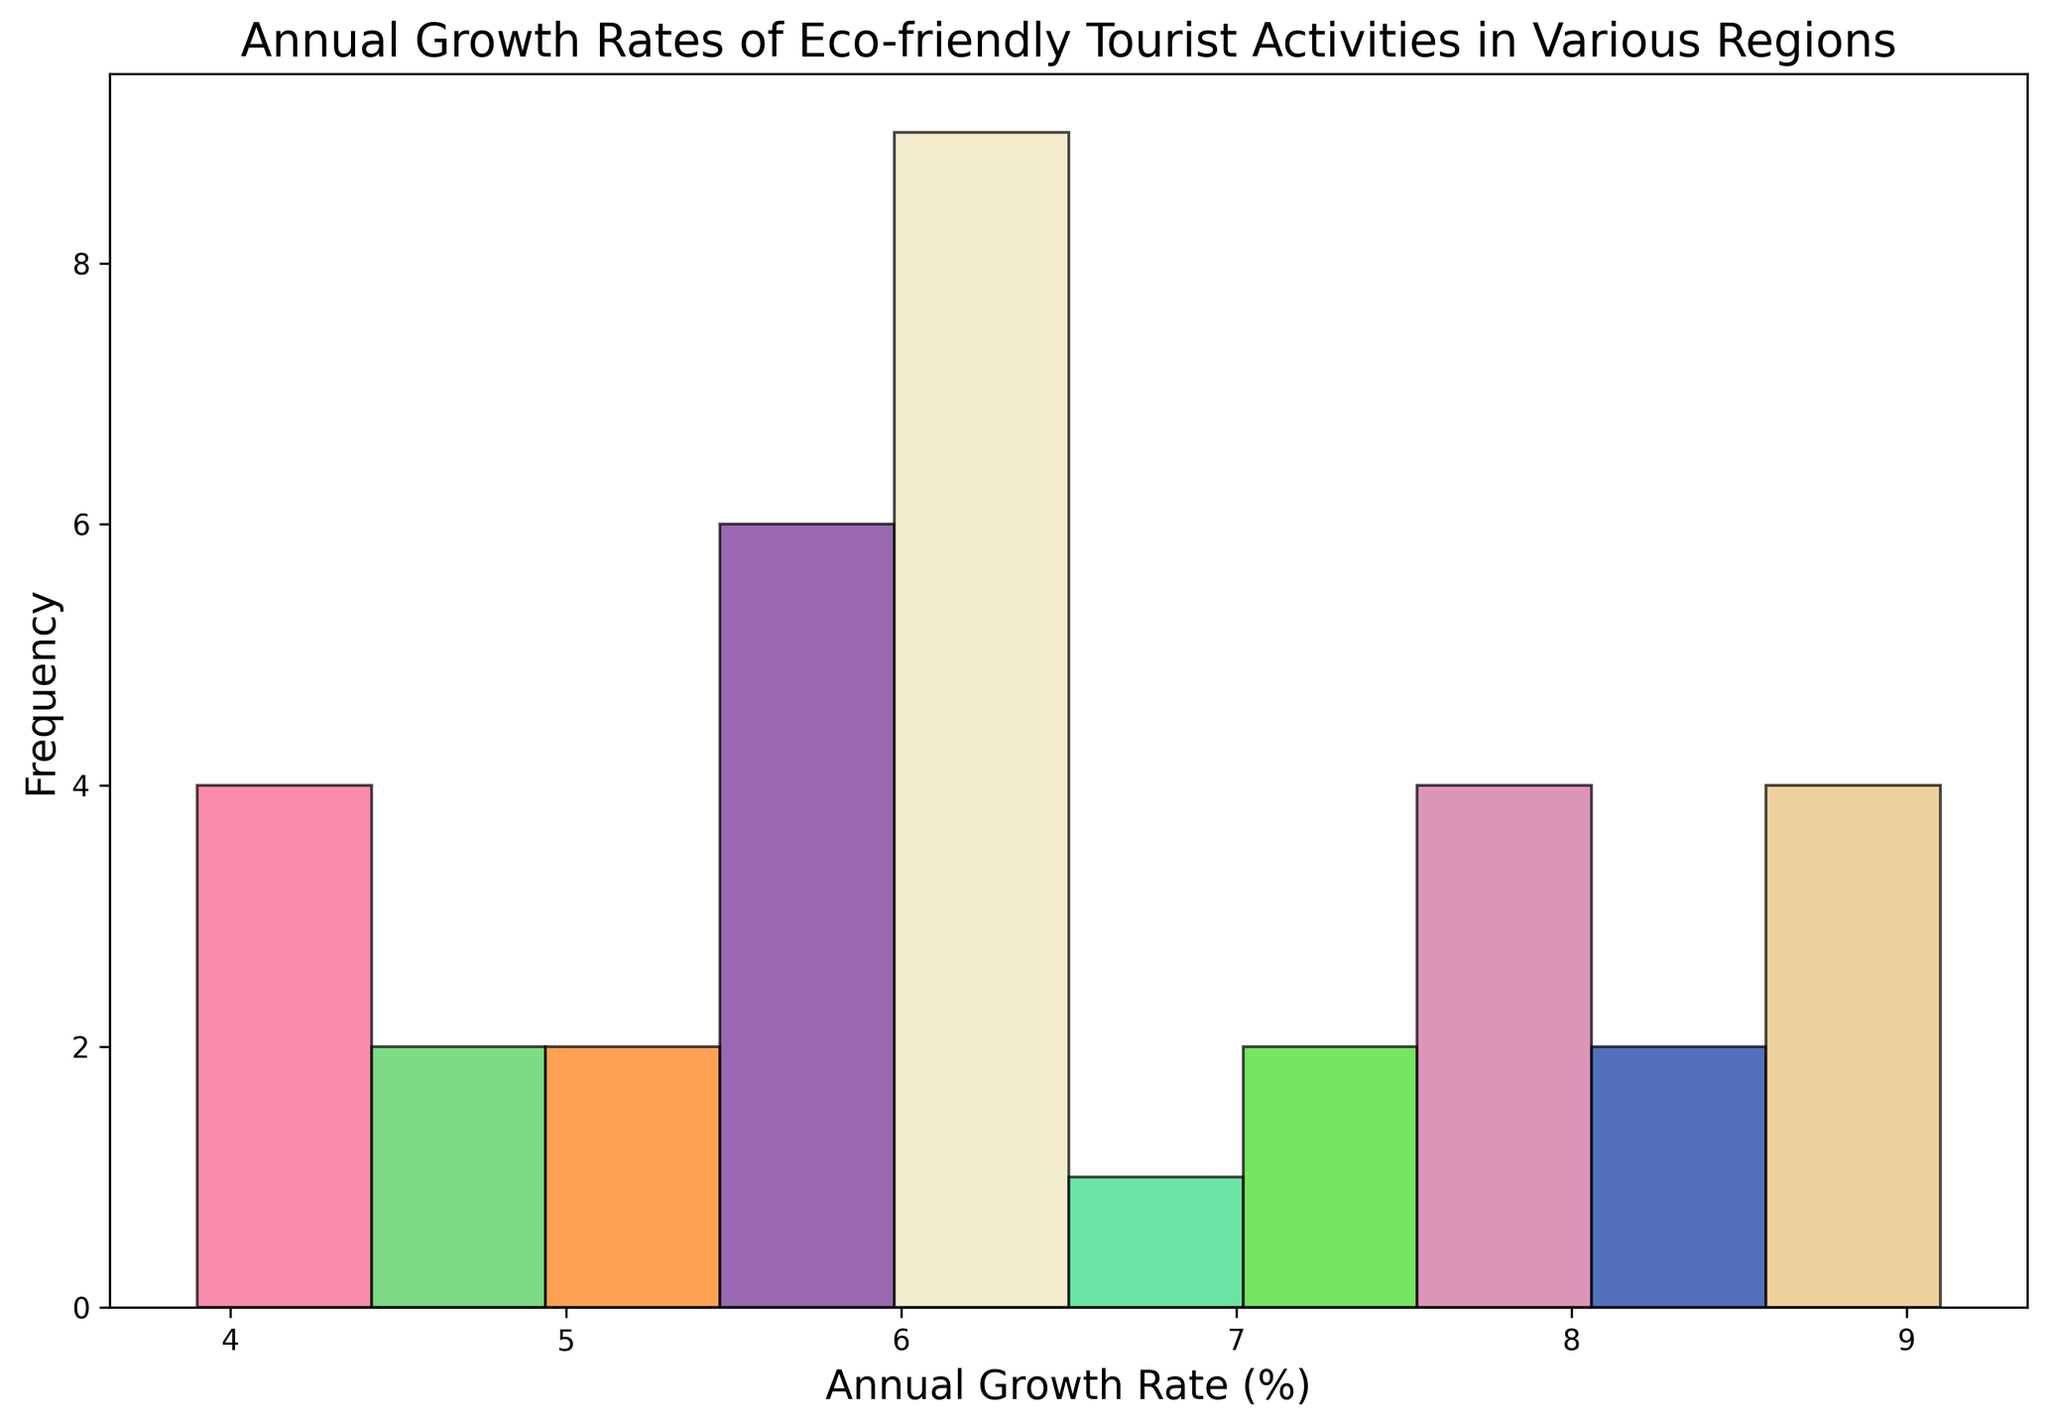What's the most common range of annual growth rates for eco-friendly tourist activities in the histogram? By identifying the peak(s) of the histogram bars, we observe which range has the highest frequency. The tallest bar represents the range with the highest number of observations.
Answer: 7-8% Which range of annual growth rates has the least frequency of eco-friendly tourist activities? Look for the shortest bar in the histogram to determine which range of annual growth rates is least frequent. This requires visual comparison of the heights of all bars in the histogram.
Answer: 3-4% How many regions have an annual growth rate between 8% and 9%? Count the number of data points that fall within the 8% to 9% range by observing the corresponding bar's height. Each bar's height represents the frequency of values within that range.
Answer: 5 Compare the frequencies of annual growth rates between the ranges of 5-6% and 6-7%. Which is higher? Examine the heights of the histogram bars for these two ranges. The taller bar indicates a higher frequency.
Answer: 5-6% What is the average annual growth rate for the regions with the highest frequency range in the histogram? First, identify the range with the highest frequency. Next, consider the midpoint of this range as a good estimate for the average growth rate there.
Answer: 7.5% What is the visual difference between the frequencies of annual growth rates in the 4-5% and 8-9% ranges? Compare the heights of the bars corresponding to the 4-5% range and the 8-9% range. This visual comparison shows the difference in frequencies.
Answer: 4-5% is lower than 8-9% Which color is predominantly used for the highest frequency bar in the histogram? Observe the bar with the highest frequency and note its fill color. Each bar has a unique randomly assigned color.
Answer: Varies Compare the visual representation of annual growth rates between 6-7% and 7-8%. Which category appears more visually significant? Look at the histogram bars and compare the heights of the bars representing the 6-7% range and the 7-8% range. The taller bar appears more visually significant.
Answer: 7-8% Find the sum of frequencies for the growth rate ranges above 6%. Identify the bars representing growth rates above 6% (6-7%, 7-8%, 8-9%) and sum their frequencies.
Answer: Sum of the frequencies for 6-7%, 7-8%, and 8-9% How does the frequency of growth rates in the 7-8% range compare with the combined frequency of growth rates in the 3-4% and 5-6% ranges? First, identify the frequency of the 7-8% range from the histogram. Then, add the frequencies of the 3-4% and 5-6% ranges and compare.
Answer: 7-8% is higher 